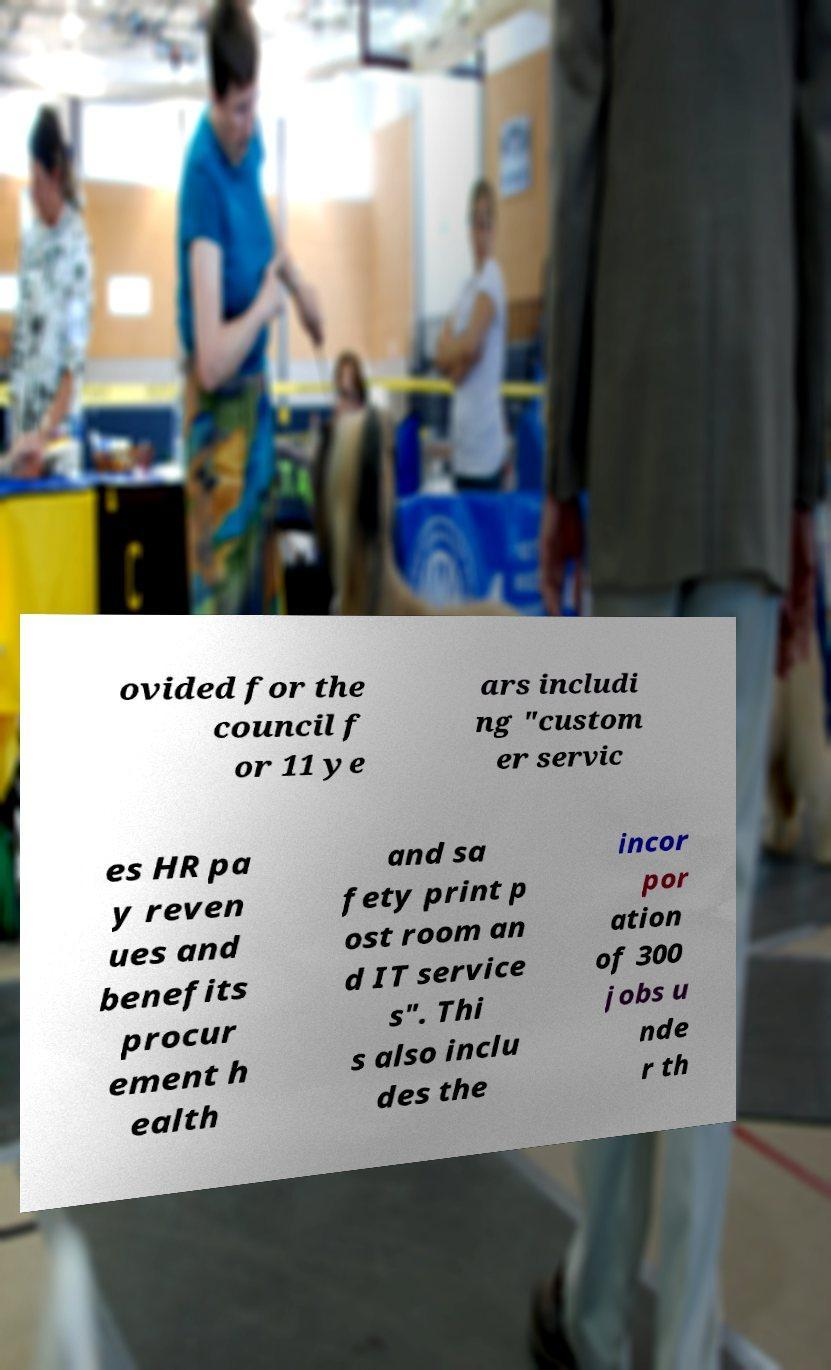What messages or text are displayed in this image? I need them in a readable, typed format. ovided for the council f or 11 ye ars includi ng "custom er servic es HR pa y reven ues and benefits procur ement h ealth and sa fety print p ost room an d IT service s". Thi s also inclu des the incor por ation of 300 jobs u nde r th 